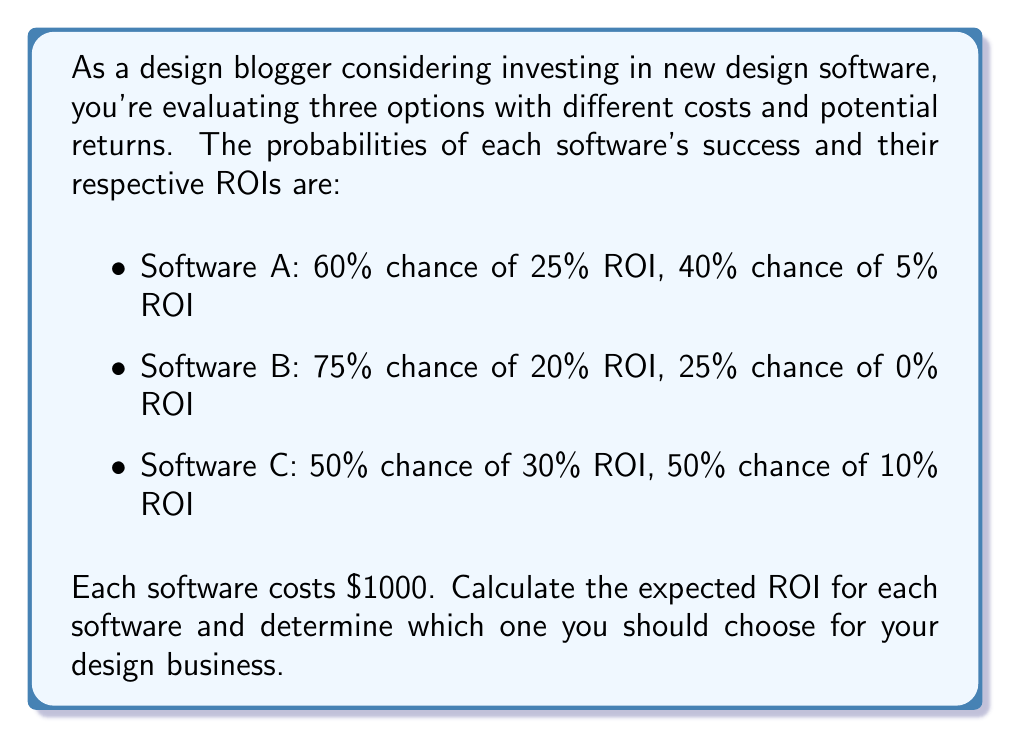Can you solve this math problem? To solve this problem, we need to calculate the expected ROI for each software option:

1. Calculate the expected ROI for Software A:
   $E(ROI_A) = 0.60 \times 25\% + 0.40 \times 5\%$
   $E(ROI_A) = 15\% + 2\% = 17\%$

2. Calculate the expected ROI for Software B:
   $E(ROI_B) = 0.75 \times 20\% + 0.25 \times 0\%$
   $E(ROI_B) = 15\% + 0\% = 15\%$

3. Calculate the expected ROI for Software C:
   $E(ROI_C) = 0.50 \times 30\% + 0.50 \times 10\%$
   $E(ROI_C) = 15\% + 5\% = 20\%$

4. Compare the expected ROIs:
   Software A: 17%
   Software B: 15%
   Software C: 20%

5. To determine the expected return in dollars, multiply the expected ROI by the cost:
   Software A: $1000 \times 17\% = $170$
   Software B: $1000 \times 15\% = $150$
   Software C: $1000 \times 20\% = $200$

Based on these calculations, Software C has the highest expected ROI at 20%, which translates to an expected return of $200 on a $1000 investment.
Answer: Choose Software C with an expected ROI of 20% ($200 return on $1000 investment). 